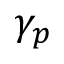Convert formula to latex. <formula><loc_0><loc_0><loc_500><loc_500>\gamma _ { p }</formula> 